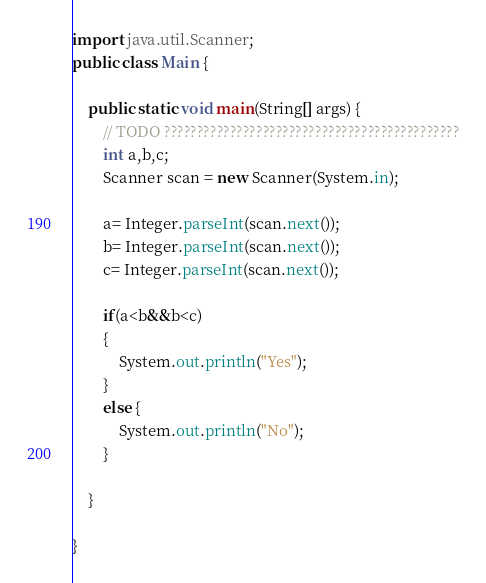Convert code to text. <code><loc_0><loc_0><loc_500><loc_500><_Java_>import java.util.Scanner;
public class Main {

	public static void main(String[] args) {
		// TODO ?????????????????????????????????????????????
		int a,b,c;
		Scanner scan = new Scanner(System.in);

	    a= Integer.parseInt(scan.next());
	    b= Integer.parseInt(scan.next());
	    c= Integer.parseInt(scan.next());
	    
	    if(a<b&&b<c)
	    {
	    	System.out.println("Yes");
	    }
	    else {
	    	System.out.println("No");
	    }
	    
	}

}</code> 